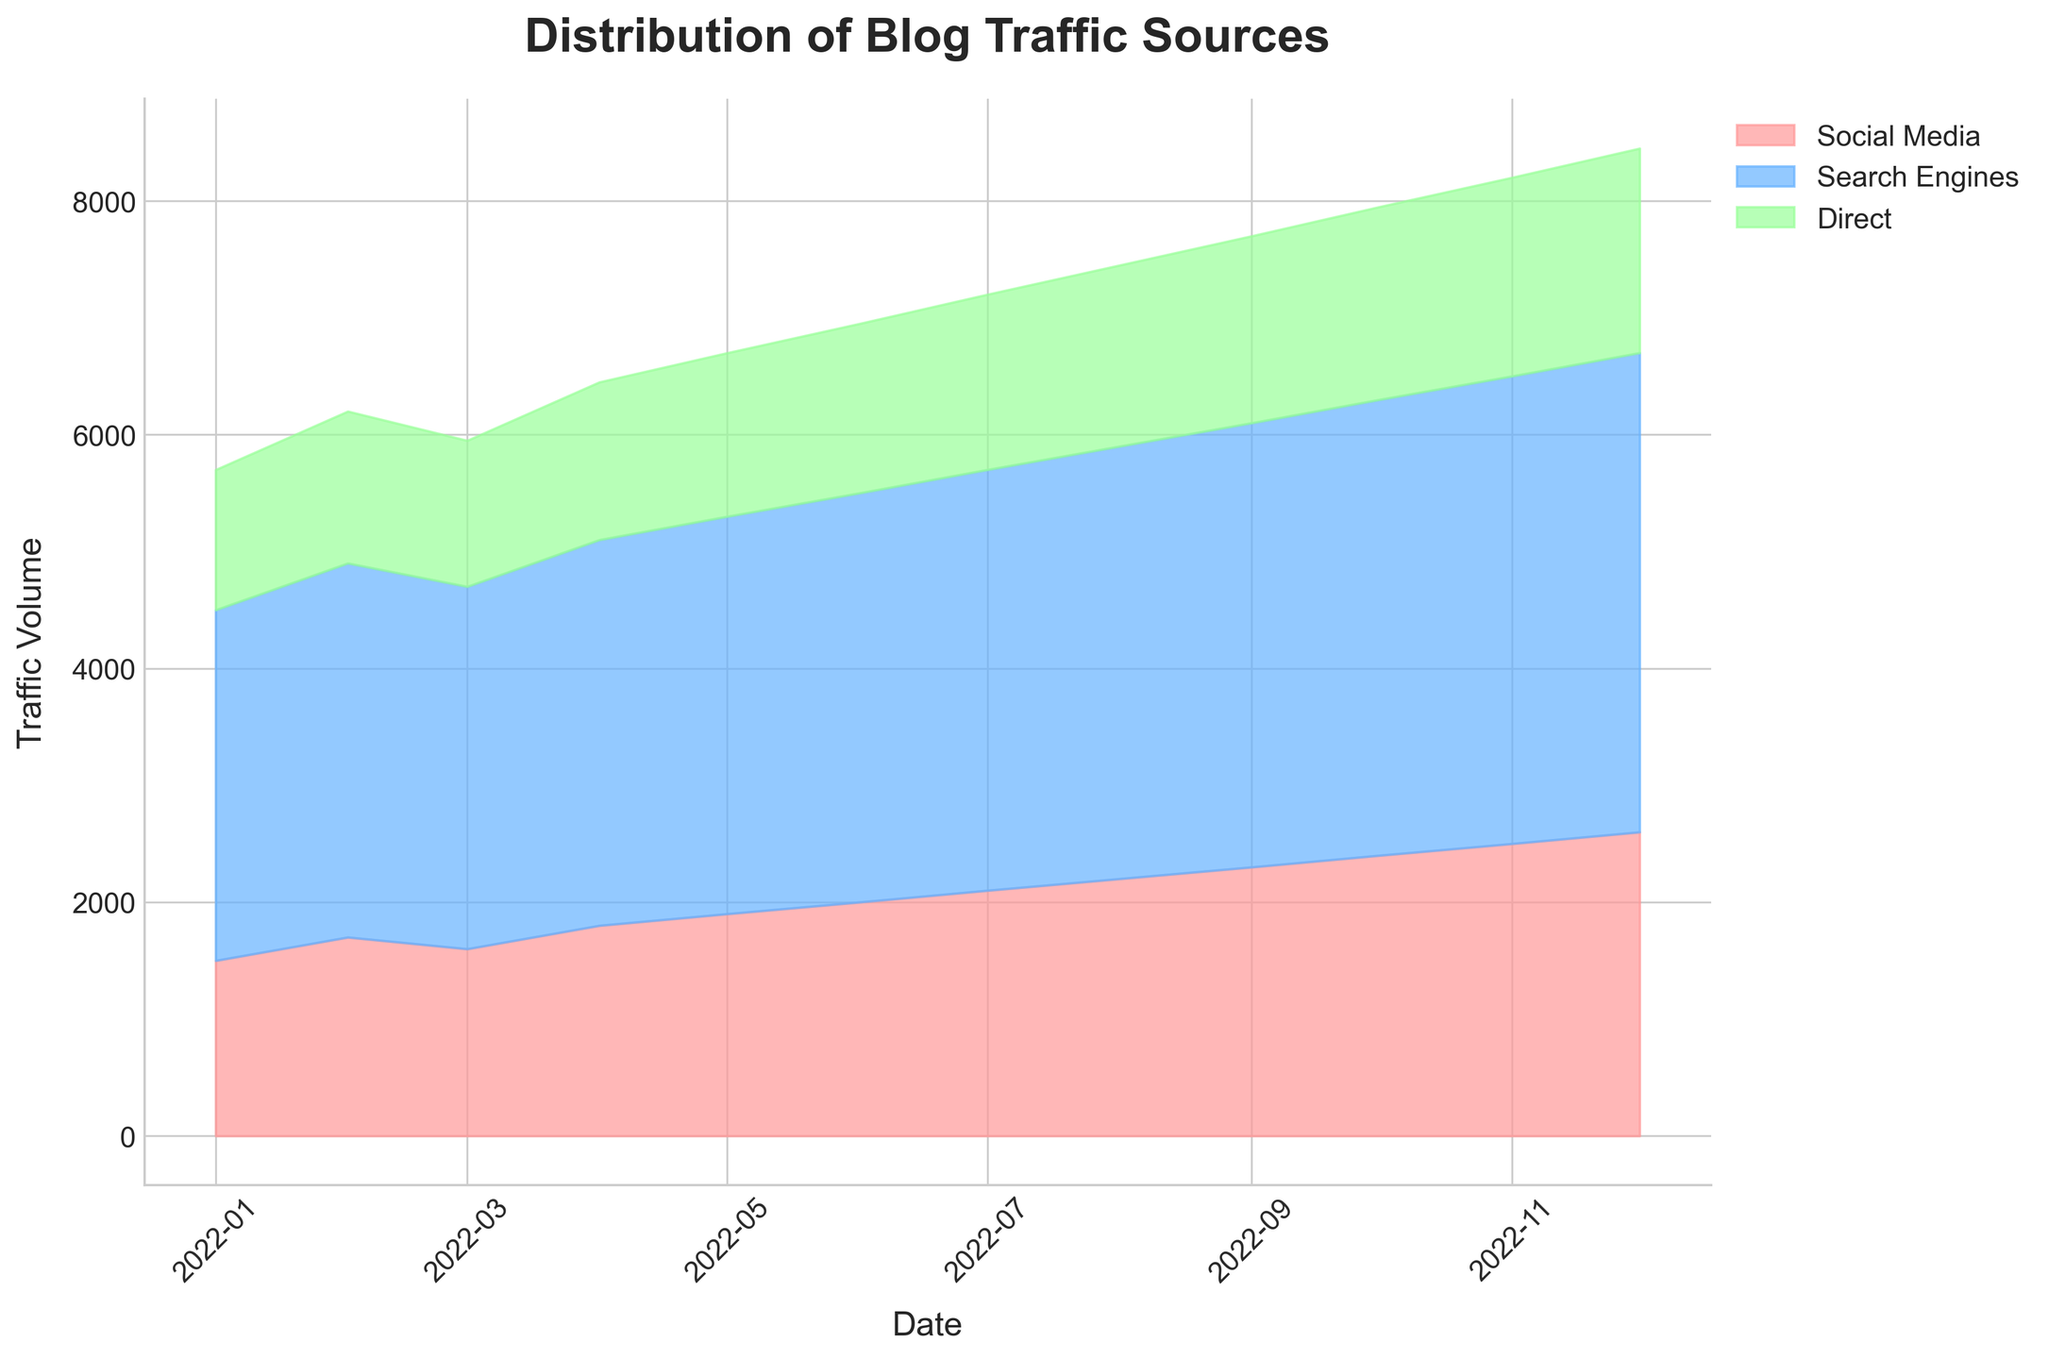What is the title of the figure? The title of the figure is usually displayed at the top. Here, it says "Distribution of Blog Traffic Sources", which indicates the nature and scope of the data depicted.
Answer: Distribution of Blog Traffic Sources Which traffic source shows a steady increase over the year? By observing the area under the curve of each traffic source, the "Search Engines" area consistently grows larger month by month, indicating a steady increase.
Answer: Search Engines What is the traffic volume from social media in July 2022? Locate the month July 2022 on the x-axis, and observe the height of the region colored for "Social Media". The volume is represented as 2100.
Answer: 2100 During which month does "Direct" traffic surpass 1500? Check each month's "Direct" traffic by looking at the top of the green area. In September 2022, the "Direct" traffic is 1600, which is the first month it surpasses 1500.
Answer: September 2022 How does the traffic from "Search Engines" in March 2022 compare to that in June 2022? Look at the height of the "Search Engines" area in March and June. In March, it is 3100 while in June, it is 3500. June has more traffic from "Search Engines".
Answer: June 2022 has more traffic What is the total traffic volume in December 2022? Add up the values of social media (2600), search engines (4100), and direct traffic (1750) in December. 2600 + 4100 + 1750 results in 8450.
Answer: 8450 By how much did "Social Media" traffic increase from January to December 2022? The traffic in January is 1500 and in December it is 2600. The increase is 2600 - 1500 = 1100.
Answer: 1100 Which traffic source had the most fluctuations throughout the year? By examining the areas in the chart, "Search Engines" shows the most noticeable and steady increase without sharp fluctuations, whereas "Social Media" and "Direct" show more gradual and steady changes. Therefore, none of the traffic sources show significant fluctuations, they gradually increase.
Answer: None What proportion of the total traffic in May 2022 can be attributed to "Direct" traffic? The total traffic in May is the sum of social media (1900), search engines (3400), and direct (1400), which is 1900 + 3400 + 1400 = 6700. The proportion for "Direct" is 1400 / 6700 ≈ 0.209 (21%).
Answer: 21% In which month did "Search Engines" first reach a traffic volume of 4000? Check each month and locate when the "Search Engines" area height reaches 4000. It first happens in November 2022.
Answer: November 2022 